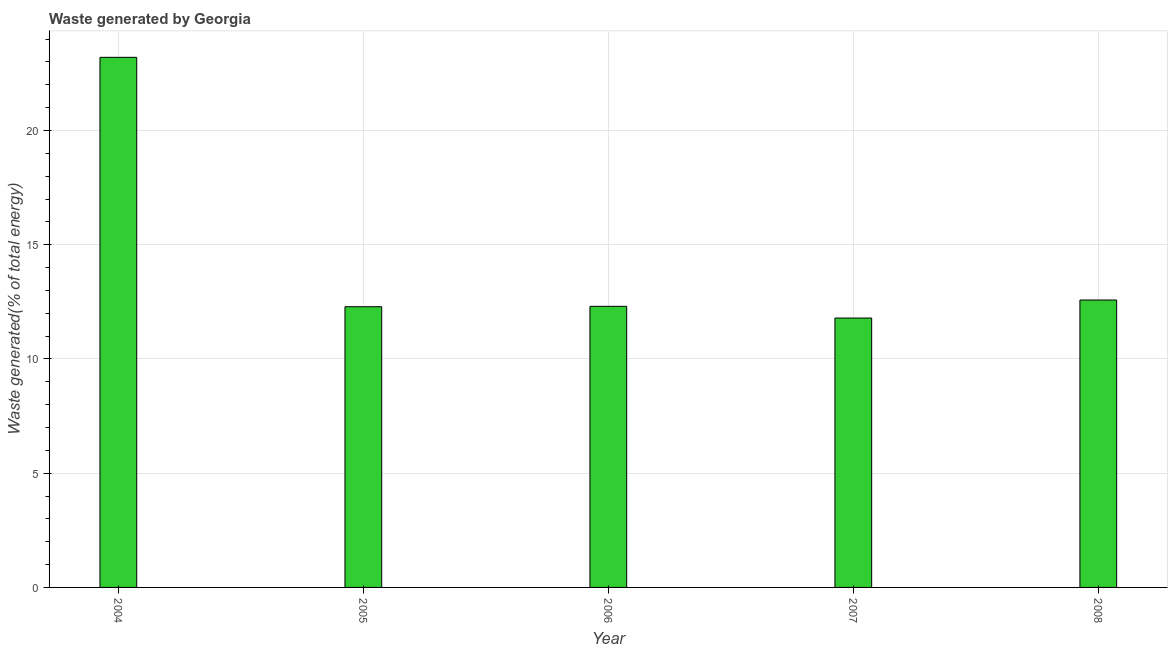Does the graph contain any zero values?
Your answer should be compact. No. What is the title of the graph?
Ensure brevity in your answer.  Waste generated by Georgia. What is the label or title of the X-axis?
Keep it short and to the point. Year. What is the label or title of the Y-axis?
Keep it short and to the point. Waste generated(% of total energy). What is the amount of waste generated in 2004?
Keep it short and to the point. 23.2. Across all years, what is the maximum amount of waste generated?
Offer a terse response. 23.2. Across all years, what is the minimum amount of waste generated?
Provide a short and direct response. 11.79. In which year was the amount of waste generated maximum?
Your answer should be very brief. 2004. What is the sum of the amount of waste generated?
Provide a short and direct response. 72.17. What is the difference between the amount of waste generated in 2004 and 2008?
Your answer should be very brief. 10.62. What is the average amount of waste generated per year?
Your response must be concise. 14.43. What is the median amount of waste generated?
Keep it short and to the point. 12.3. In how many years, is the amount of waste generated greater than 10 %?
Offer a terse response. 5. What is the ratio of the amount of waste generated in 2007 to that in 2008?
Make the answer very short. 0.94. Is the amount of waste generated in 2006 less than that in 2008?
Offer a terse response. Yes. What is the difference between the highest and the second highest amount of waste generated?
Your answer should be very brief. 10.62. Is the sum of the amount of waste generated in 2004 and 2005 greater than the maximum amount of waste generated across all years?
Ensure brevity in your answer.  Yes. What is the difference between the highest and the lowest amount of waste generated?
Provide a short and direct response. 11.41. In how many years, is the amount of waste generated greater than the average amount of waste generated taken over all years?
Offer a very short reply. 1. How many bars are there?
Provide a short and direct response. 5. How many years are there in the graph?
Your answer should be very brief. 5. What is the Waste generated(% of total energy) in 2004?
Your response must be concise. 23.2. What is the Waste generated(% of total energy) of 2005?
Offer a very short reply. 12.29. What is the Waste generated(% of total energy) in 2006?
Make the answer very short. 12.3. What is the Waste generated(% of total energy) in 2007?
Ensure brevity in your answer.  11.79. What is the Waste generated(% of total energy) in 2008?
Offer a very short reply. 12.58. What is the difference between the Waste generated(% of total energy) in 2004 and 2005?
Your answer should be compact. 10.92. What is the difference between the Waste generated(% of total energy) in 2004 and 2006?
Offer a terse response. 10.9. What is the difference between the Waste generated(% of total energy) in 2004 and 2007?
Your response must be concise. 11.41. What is the difference between the Waste generated(% of total energy) in 2004 and 2008?
Keep it short and to the point. 10.62. What is the difference between the Waste generated(% of total energy) in 2005 and 2006?
Offer a very short reply. -0.02. What is the difference between the Waste generated(% of total energy) in 2005 and 2007?
Your answer should be very brief. 0.5. What is the difference between the Waste generated(% of total energy) in 2005 and 2008?
Keep it short and to the point. -0.29. What is the difference between the Waste generated(% of total energy) in 2006 and 2007?
Your answer should be compact. 0.51. What is the difference between the Waste generated(% of total energy) in 2006 and 2008?
Make the answer very short. -0.28. What is the difference between the Waste generated(% of total energy) in 2007 and 2008?
Keep it short and to the point. -0.79. What is the ratio of the Waste generated(% of total energy) in 2004 to that in 2005?
Your answer should be compact. 1.89. What is the ratio of the Waste generated(% of total energy) in 2004 to that in 2006?
Make the answer very short. 1.89. What is the ratio of the Waste generated(% of total energy) in 2004 to that in 2007?
Make the answer very short. 1.97. What is the ratio of the Waste generated(% of total energy) in 2004 to that in 2008?
Provide a succinct answer. 1.84. What is the ratio of the Waste generated(% of total energy) in 2005 to that in 2007?
Offer a terse response. 1.04. What is the ratio of the Waste generated(% of total energy) in 2006 to that in 2007?
Make the answer very short. 1.04. What is the ratio of the Waste generated(% of total energy) in 2007 to that in 2008?
Provide a succinct answer. 0.94. 